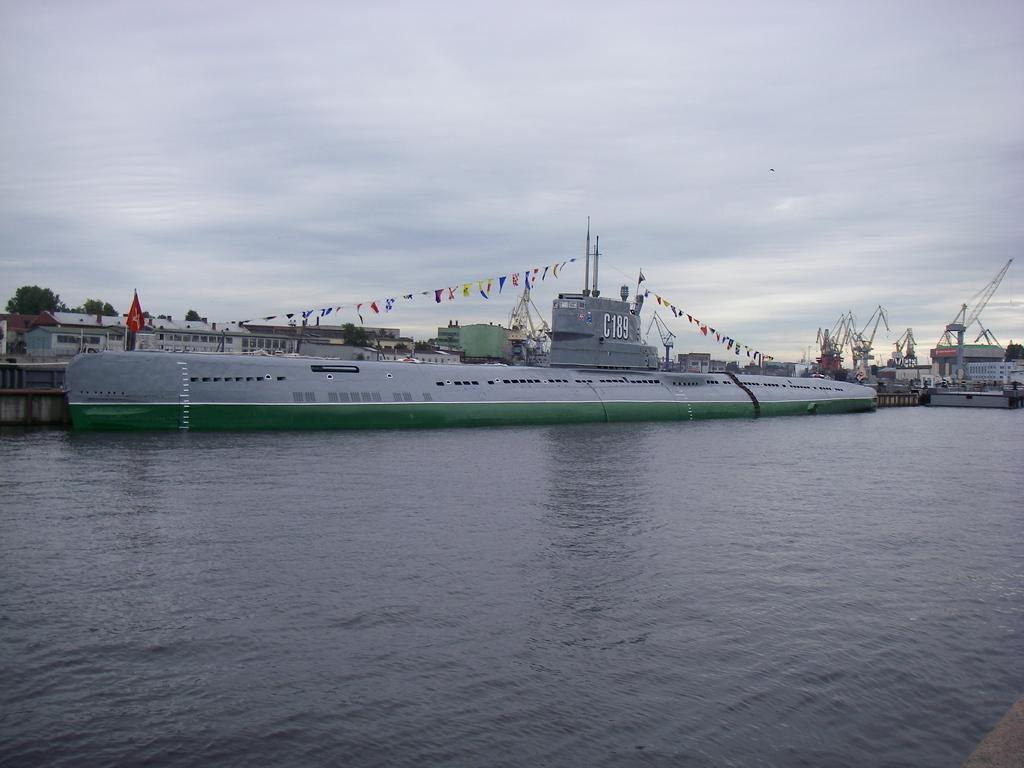What is the main subject of the image? The main subject of the image is a submarine. Where is the submarine located in the image? The submarine is on the water. What can be seen in the background of the image? There are trees and buildings in the background of the image. What is the condition of the sky in the image? The sky is clear in the image. What is the price of the feather in the image? There is no feather present in the image, so it is not possible to determine its price. 